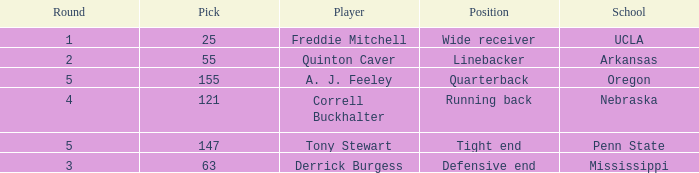What position did the player who was picked in round 3 play? Defensive end. 